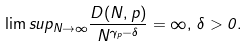Convert formula to latex. <formula><loc_0><loc_0><loc_500><loc_500>\lim s u p _ { N \to \infty } \frac { D ( N , p ) } { N ^ { \gamma _ { p } - \delta } } = \infty , \, \delta > 0 .</formula> 